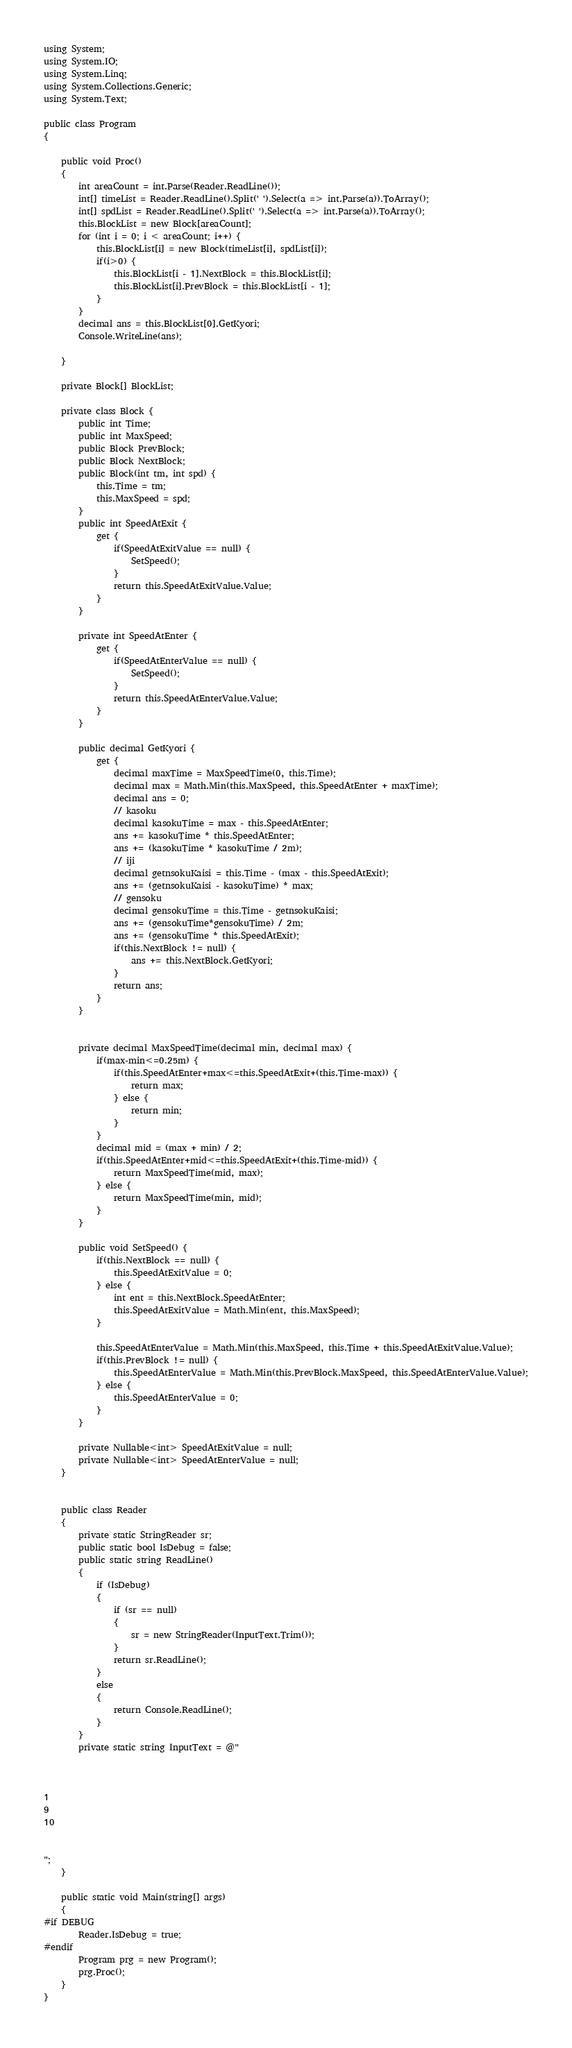<code> <loc_0><loc_0><loc_500><loc_500><_C#_>using System;
using System.IO;
using System.Linq;
using System.Collections.Generic;
using System.Text;

public class Program
{

    public void Proc()
    {
        int areaCount = int.Parse(Reader.ReadLine());
        int[] timeList = Reader.ReadLine().Split(' ').Select(a => int.Parse(a)).ToArray();
        int[] spdList = Reader.ReadLine().Split(' ').Select(a => int.Parse(a)).ToArray();
        this.BlockList = new Block[areaCount];
        for (int i = 0; i < areaCount; i++) {
            this.BlockList[i] = new Block(timeList[i], spdList[i]);
            if(i>0) {
                this.BlockList[i - 1].NextBlock = this.BlockList[i];
                this.BlockList[i].PrevBlock = this.BlockList[i - 1];
            }
        }
        decimal ans = this.BlockList[0].GetKyori;
        Console.WriteLine(ans);
    
    }

    private Block[] BlockList;

    private class Block {
        public int Time;
        public int MaxSpeed;
        public Block PrevBlock;
        public Block NextBlock;
        public Block(int tm, int spd) {
            this.Time = tm;
            this.MaxSpeed = spd;
        }
        public int SpeedAtExit {
            get {
                if(SpeedAtExitValue == null) {
                    SetSpeed();
                }
                return this.SpeedAtExitValue.Value;
            }            
        }

        private int SpeedAtEnter {
            get {
                if(SpeedAtEnterValue == null) {
                    SetSpeed();
                }
                return this.SpeedAtEnterValue.Value;
            }
        }

        public decimal GetKyori {
            get {
                decimal maxTime = MaxSpeedTime(0, this.Time);
                decimal max = Math.Min(this.MaxSpeed, this.SpeedAtEnter + maxTime);
                decimal ans = 0;
                // kasoku
                decimal kasokuTime = max - this.SpeedAtEnter;
                ans += kasokuTime * this.SpeedAtEnter;
                ans += (kasokuTime * kasokuTime / 2m);
                // iji
                decimal getnsokuKaisi = this.Time - (max - this.SpeedAtExit);
                ans += (getnsokuKaisi - kasokuTime) * max;
                // gensoku
                decimal gensokuTime = this.Time - getnsokuKaisi;
                ans += (gensokuTime*gensokuTime) / 2m;
                ans += (gensokuTime * this.SpeedAtExit);
                if(this.NextBlock != null) {
                    ans += this.NextBlock.GetKyori;
                }
                return ans;
            }
        }


        private decimal MaxSpeedTime(decimal min, decimal max) {
            if(max-min<=0.25m) {
                if(this.SpeedAtEnter+max<=this.SpeedAtExit+(this.Time-max)) {
                    return max;
                } else {
                    return min;
                }
            }
            decimal mid = (max + min) / 2;
            if(this.SpeedAtEnter+mid<=this.SpeedAtExit+(this.Time-mid)) {
                return MaxSpeedTime(mid, max);
            } else {
                return MaxSpeedTime(min, mid);
            }
        }

        public void SetSpeed() {
            if(this.NextBlock == null) {
                this.SpeedAtExitValue = 0;
            } else {
                int ent = this.NextBlock.SpeedAtEnter;
                this.SpeedAtExitValue = Math.Min(ent, this.MaxSpeed);
            }

            this.SpeedAtEnterValue = Math.Min(this.MaxSpeed, this.Time + this.SpeedAtExitValue.Value);
            if(this.PrevBlock != null) {
                this.SpeedAtEnterValue = Math.Min(this.PrevBlock.MaxSpeed, this.SpeedAtEnterValue.Value);
            } else {
                this.SpeedAtEnterValue = 0;
            }
        }

        private Nullable<int> SpeedAtExitValue = null;
        private Nullable<int> SpeedAtEnterValue = null;
    }


    public class Reader
    {
        private static StringReader sr;
        public static bool IsDebug = false;
        public static string ReadLine()
        {
            if (IsDebug)
            {
                if (sr == null)
                {
                    sr = new StringReader(InputText.Trim());
                }
                return sr.ReadLine();
            }
            else
            {
                return Console.ReadLine();
            }
        }
        private static string InputText = @"



1
9
10


";
    }

    public static void Main(string[] args)
    {
#if DEBUG
        Reader.IsDebug = true;
#endif
        Program prg = new Program();
        prg.Proc();
    }
}
</code> 